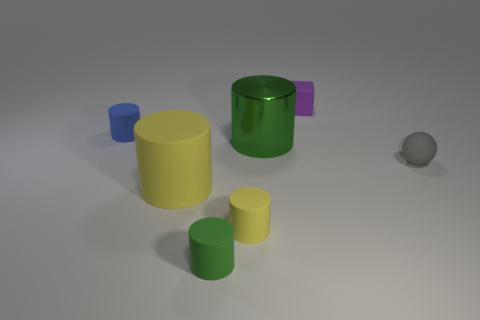Is there a large cyan matte cylinder?
Offer a terse response. No. There is a green thing that is in front of the yellow thing behind the small yellow rubber cylinder; what is its shape?
Keep it short and to the point. Cylinder. How many objects are green cylinders behind the small yellow thing or yellow things on the left side of the small yellow cylinder?
Give a very brief answer. 2. There is a purple cube that is the same size as the gray sphere; what is it made of?
Offer a very short reply. Rubber. The metal thing is what color?
Keep it short and to the point. Green. There is a tiny object that is both in front of the small purple matte cube and behind the rubber ball; what material is it?
Give a very brief answer. Rubber. There is a yellow cylinder that is to the left of the green cylinder that is on the left side of the large green shiny cylinder; are there any gray matte spheres to the right of it?
Ensure brevity in your answer.  Yes. There is another thing that is the same color as the large metal thing; what size is it?
Make the answer very short. Small. Are there any small green objects behind the purple cube?
Keep it short and to the point. No. What number of other objects are the same shape as the small green rubber object?
Provide a succinct answer. 4. 